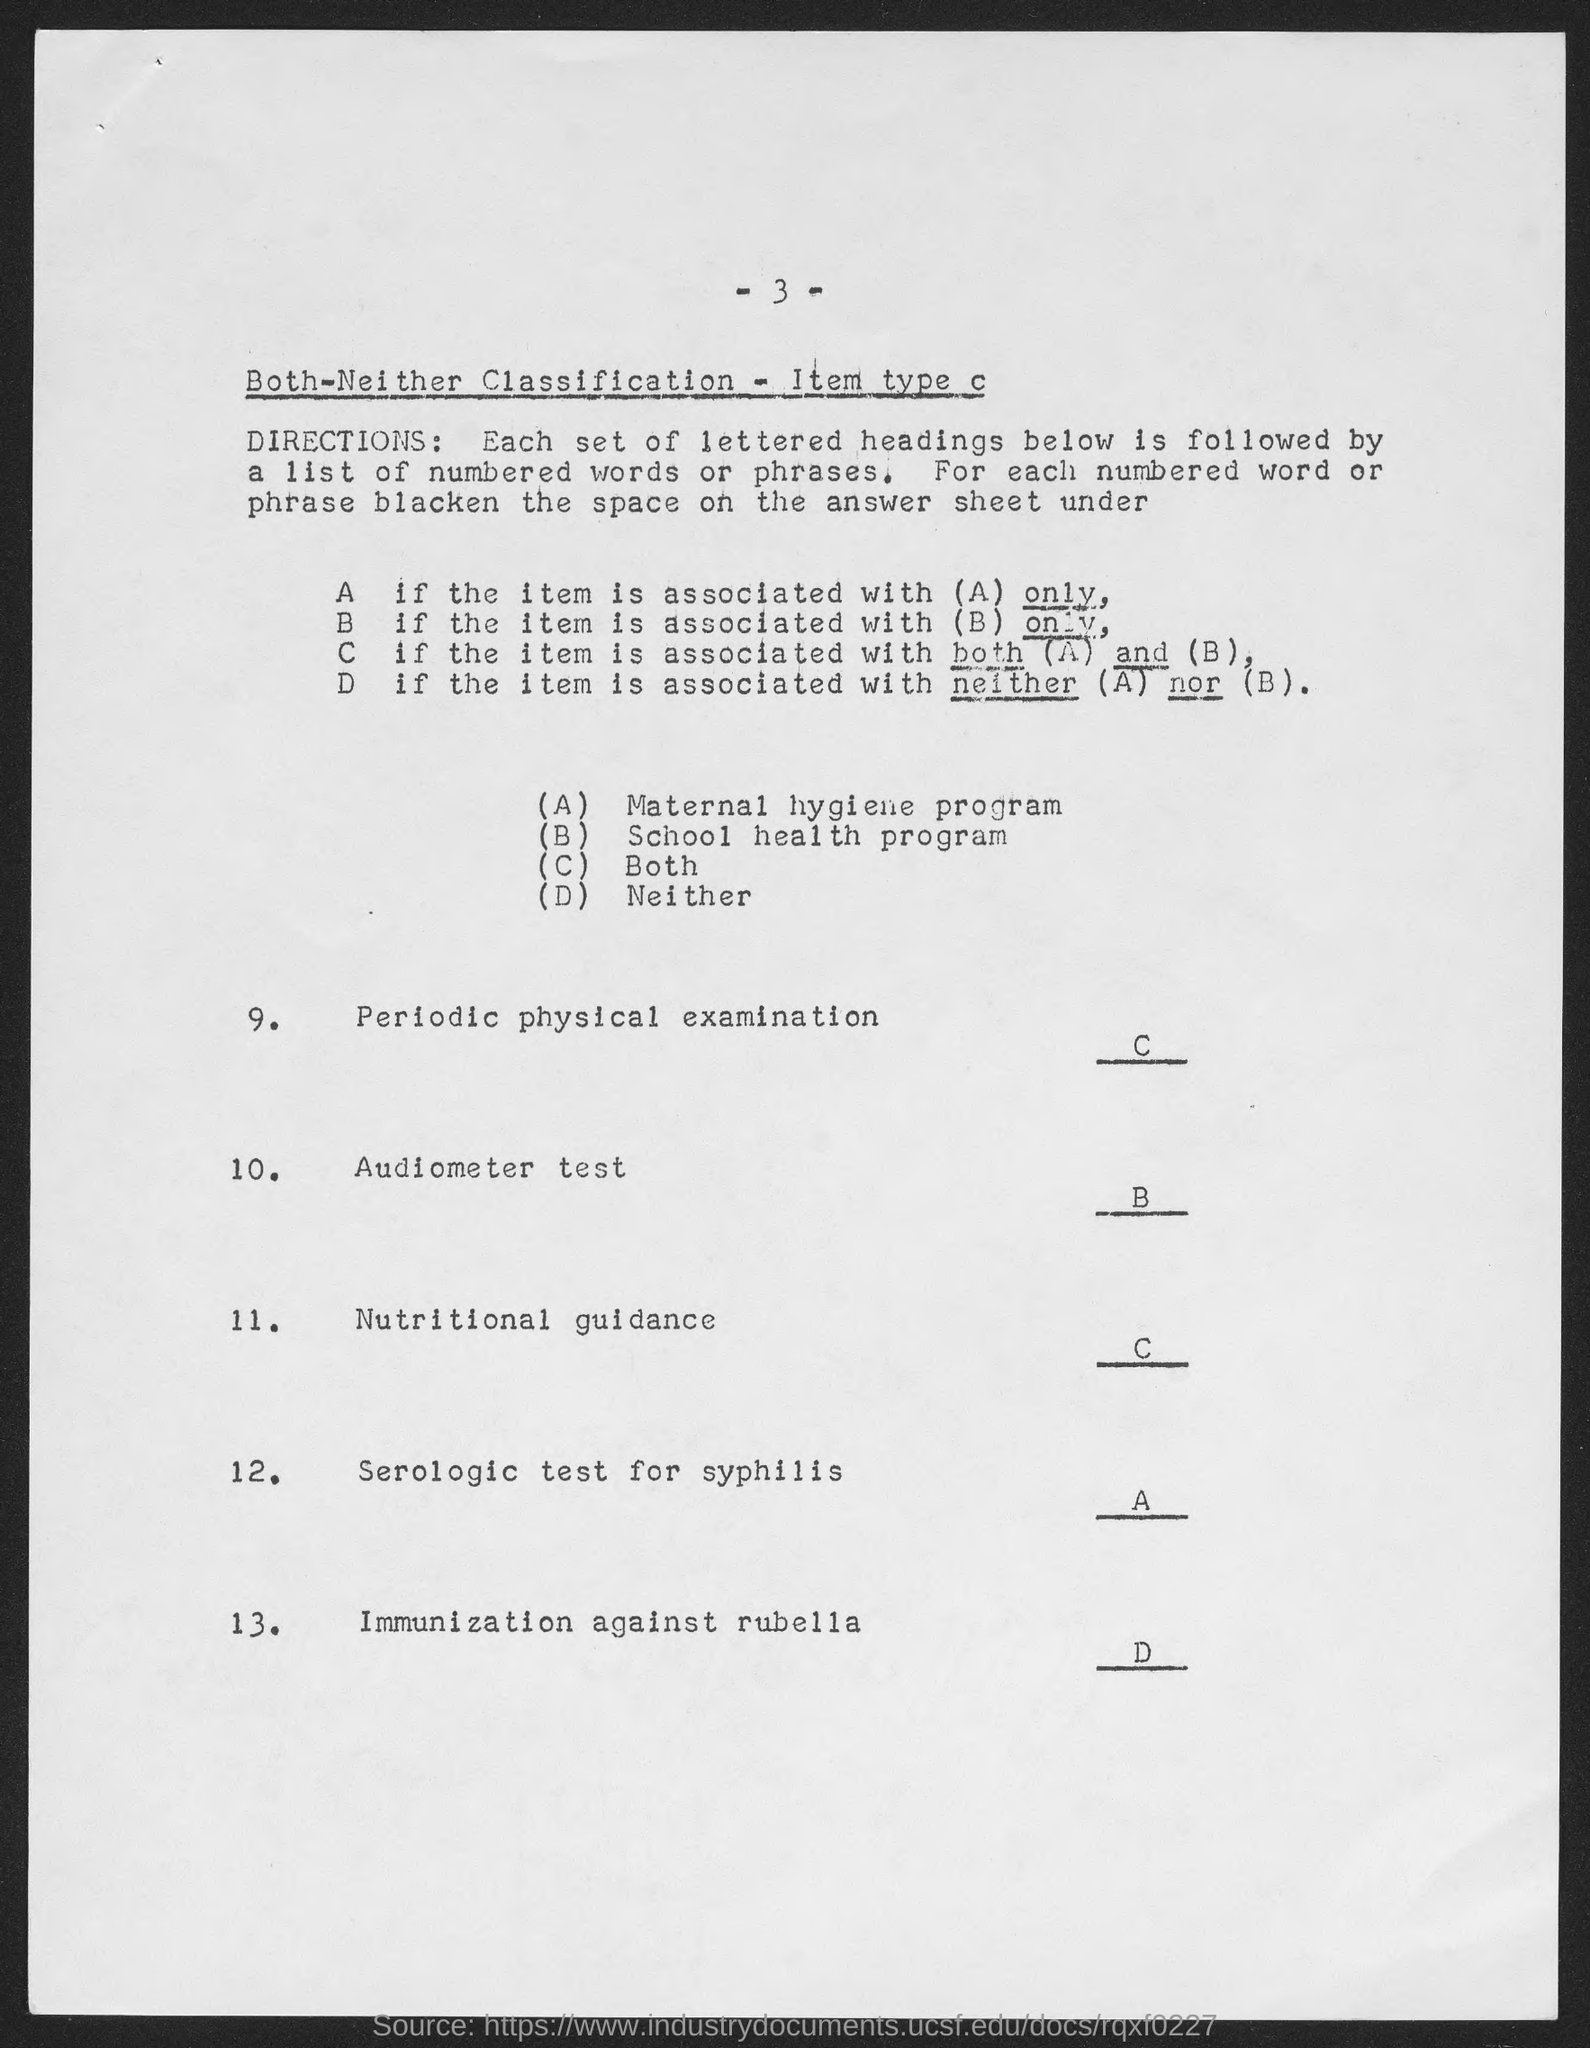Highlight a few significant elements in this photo. Periodic physical examination is recommended as C.. 